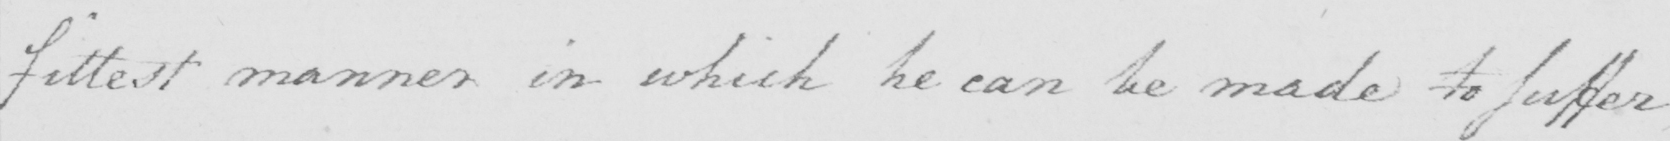Can you tell me what this handwritten text says? fittest manner in which he can be made to suffer 